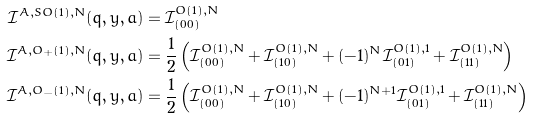Convert formula to latex. <formula><loc_0><loc_0><loc_500><loc_500>\mathcal { I } ^ { A , S O ( 1 ) , N } ( q , y , a ) & = \mathcal { I } ^ { O ( 1 ) , N } _ { ( 0 0 ) } \\ \mathcal { I } ^ { A , O _ { + } ( 1 ) , N } ( q , y , a ) & = \frac { 1 } { 2 } \left ( \mathcal { I } ^ { O ( 1 ) , N } _ { ( 0 0 ) } + \mathcal { I } ^ { O ( 1 ) , N } _ { ( 1 0 ) } + ( - 1 ) ^ { N } \mathcal { I } ^ { O ( 1 ) , 1 } _ { ( 0 1 ) } + \mathcal { I } ^ { O ( 1 ) , N } _ { ( 1 1 ) } \right ) \\ \mathcal { I } ^ { A , O _ { - } ( 1 ) , N } ( q , y , a ) & = \frac { 1 } { 2 } \left ( \mathcal { I } ^ { O ( 1 ) , N } _ { ( 0 0 ) } + \mathcal { I } ^ { O ( 1 ) , N } _ { ( 1 0 ) } + ( - 1 ) ^ { N + 1 } \mathcal { I } ^ { O ( 1 ) , 1 } _ { ( 0 1 ) } + \mathcal { I } ^ { O ( 1 ) , N } _ { ( 1 1 ) } \right )</formula> 